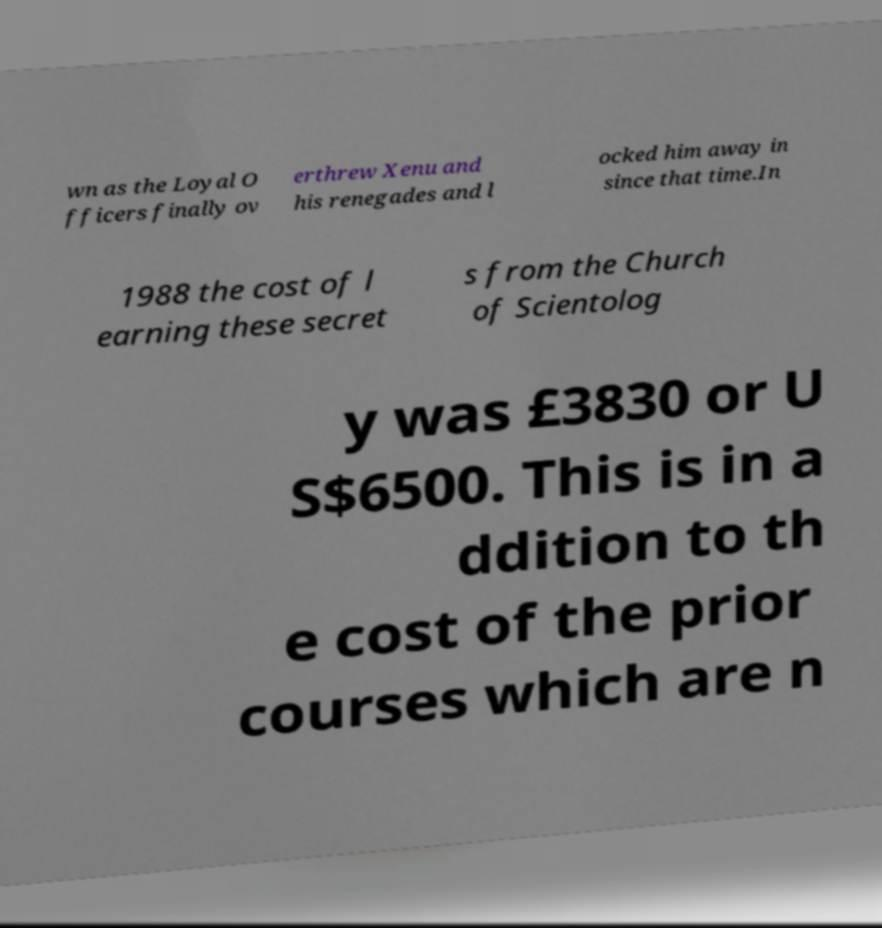Please read and relay the text visible in this image. What does it say? wn as the Loyal O fficers finally ov erthrew Xenu and his renegades and l ocked him away in since that time.In 1988 the cost of l earning these secret s from the Church of Scientolog y was £3830 or U S$6500. This is in a ddition to th e cost of the prior courses which are n 